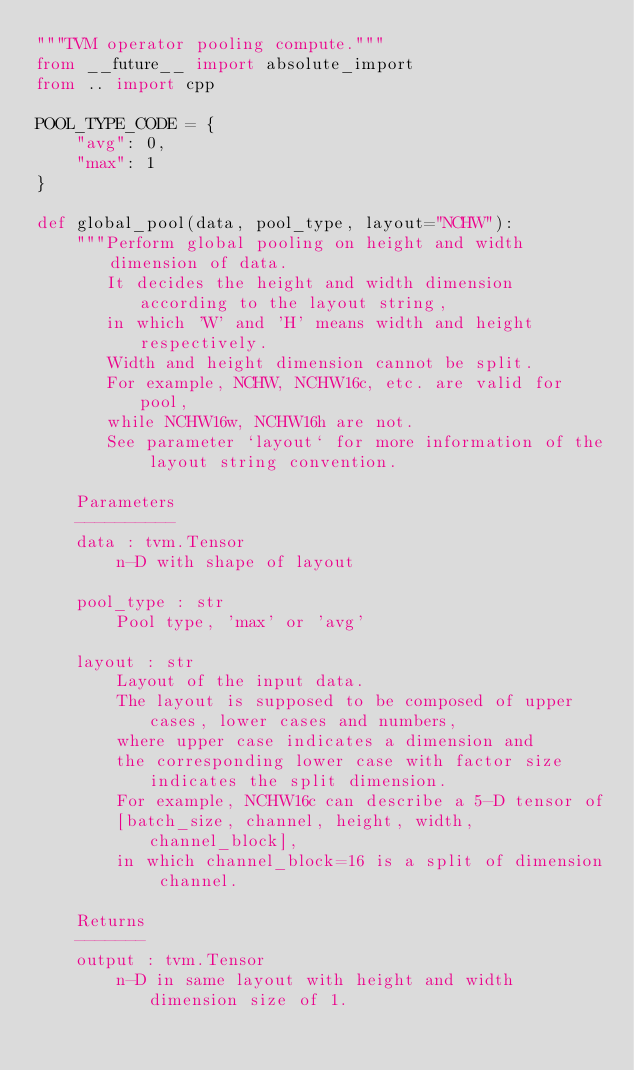<code> <loc_0><loc_0><loc_500><loc_500><_Python_>"""TVM operator pooling compute."""
from __future__ import absolute_import
from .. import cpp

POOL_TYPE_CODE = {
    "avg": 0,
    "max": 1
}

def global_pool(data, pool_type, layout="NCHW"):
    """Perform global pooling on height and width dimension of data.
       It decides the height and width dimension according to the layout string,
       in which 'W' and 'H' means width and height respectively.
       Width and height dimension cannot be split.
       For example, NCHW, NCHW16c, etc. are valid for pool,
       while NCHW16w, NCHW16h are not.
       See parameter `layout` for more information of the layout string convention.

    Parameters
    ----------
    data : tvm.Tensor
        n-D with shape of layout

    pool_type : str
        Pool type, 'max' or 'avg'

    layout : str
        Layout of the input data.
        The layout is supposed to be composed of upper cases, lower cases and numbers,
        where upper case indicates a dimension and
        the corresponding lower case with factor size indicates the split dimension.
        For example, NCHW16c can describe a 5-D tensor of
        [batch_size, channel, height, width, channel_block],
        in which channel_block=16 is a split of dimension channel.

    Returns
    -------
    output : tvm.Tensor
        n-D in same layout with height and width dimension size of 1.</code> 